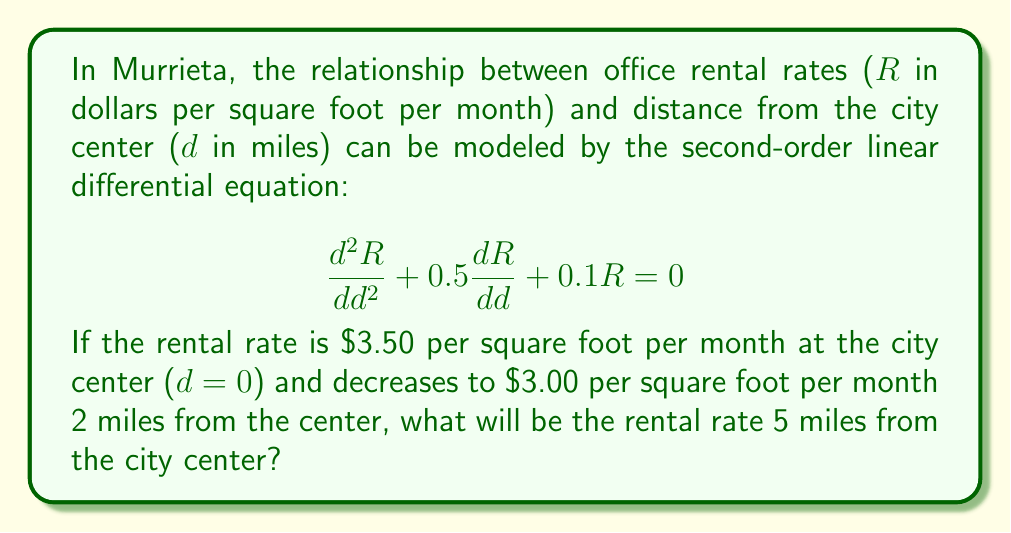Provide a solution to this math problem. To solve this problem, we need to follow these steps:

1) The general solution for this second-order linear differential equation is:

   $$R(d) = C_1e^{r_1d} + C_2e^{r_2d}$$

   where $r_1$ and $r_2$ are the roots of the characteristic equation:

   $$r^2 + 0.5r + 0.1 = 0$$

2) Solving the characteristic equation:
   
   $$r = \frac{-0.5 \pm \sqrt{0.5^2 - 4(1)(0.1)}}{2(1)} = \frac{-0.5 \pm \sqrt{0.05}}{2}$$

   $$r_1 = -0.3618, r_2 = -0.1382$$

3) Thus, our general solution is:

   $$R(d) = C_1e^{-0.3618d} + C_2e^{-0.1382d}$$

4) Now we use the given conditions to find $C_1$ and $C_2$:

   At d = 0, R = 3.50: $3.50 = C_1 + C_2$
   At d = 2, R = 3.00: $3.00 = C_1e^{-0.7236} + C_2e^{-0.2764}$

5) Solving these equations simultaneously:

   $C_1 = 1.9355$ and $C_2 = 1.5645$

6) Our final equation is:

   $$R(d) = 1.9355e^{-0.3618d} + 1.5645e^{-0.1382d}$$

7) To find the rental rate at 5 miles, we substitute d = 5:

   $$R(5) = 1.9355e^{-0.3618(5)} + 1.5645e^{-0.1382(5)}$$
Answer: $R(5) = 2.31$ dollars per square foot per month (rounded to two decimal places) 